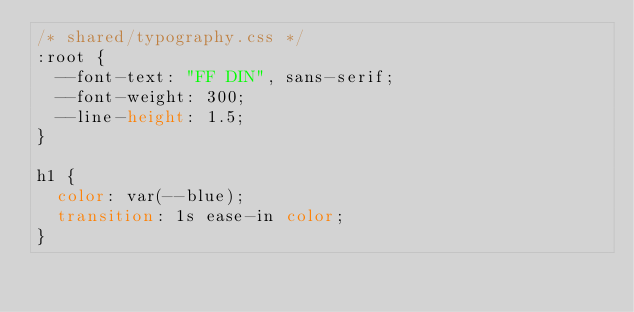<code> <loc_0><loc_0><loc_500><loc_500><_CSS_>/* shared/typography.css */
:root {
  --font-text: "FF DIN", sans-serif;
  --font-weight: 300;
  --line-height: 1.5;
}

h1 {
  color: var(--blue);
  transition: 1s ease-in color;
}
</code> 